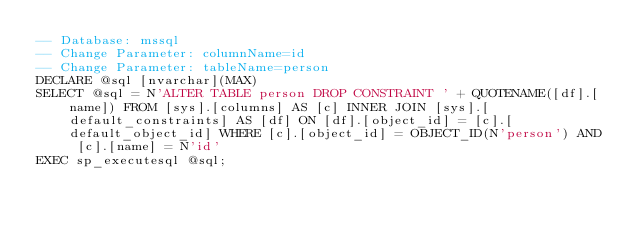Convert code to text. <code><loc_0><loc_0><loc_500><loc_500><_SQL_>-- Database: mssql
-- Change Parameter: columnName=id
-- Change Parameter: tableName=person
DECLARE @sql [nvarchar](MAX)
SELECT @sql = N'ALTER TABLE person DROP CONSTRAINT ' + QUOTENAME([df].[name]) FROM [sys].[columns] AS [c] INNER JOIN [sys].[default_constraints] AS [df] ON [df].[object_id] = [c].[default_object_id] WHERE [c].[object_id] = OBJECT_ID(N'person') AND [c].[name] = N'id'
EXEC sp_executesql @sql;
</code> 